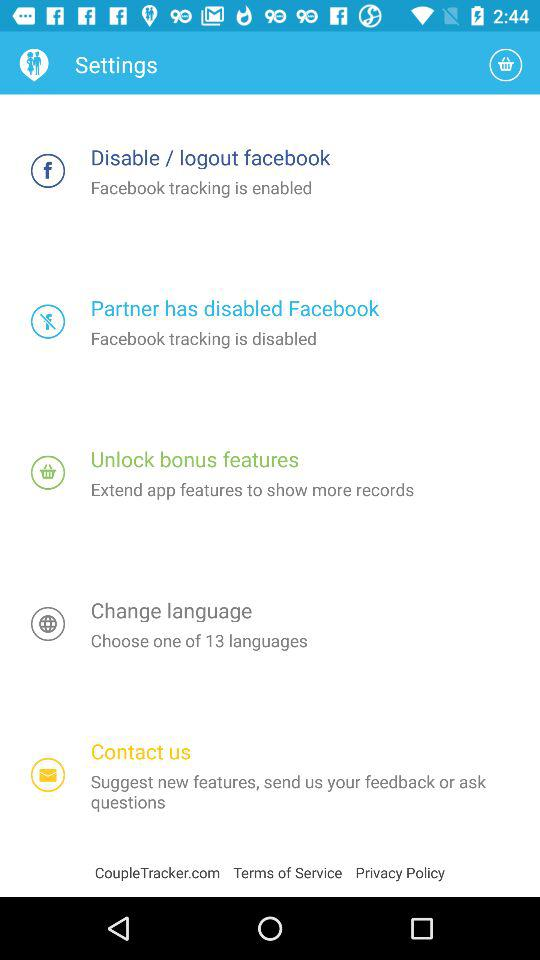How many languages in total are there? There are total 13 languages. 